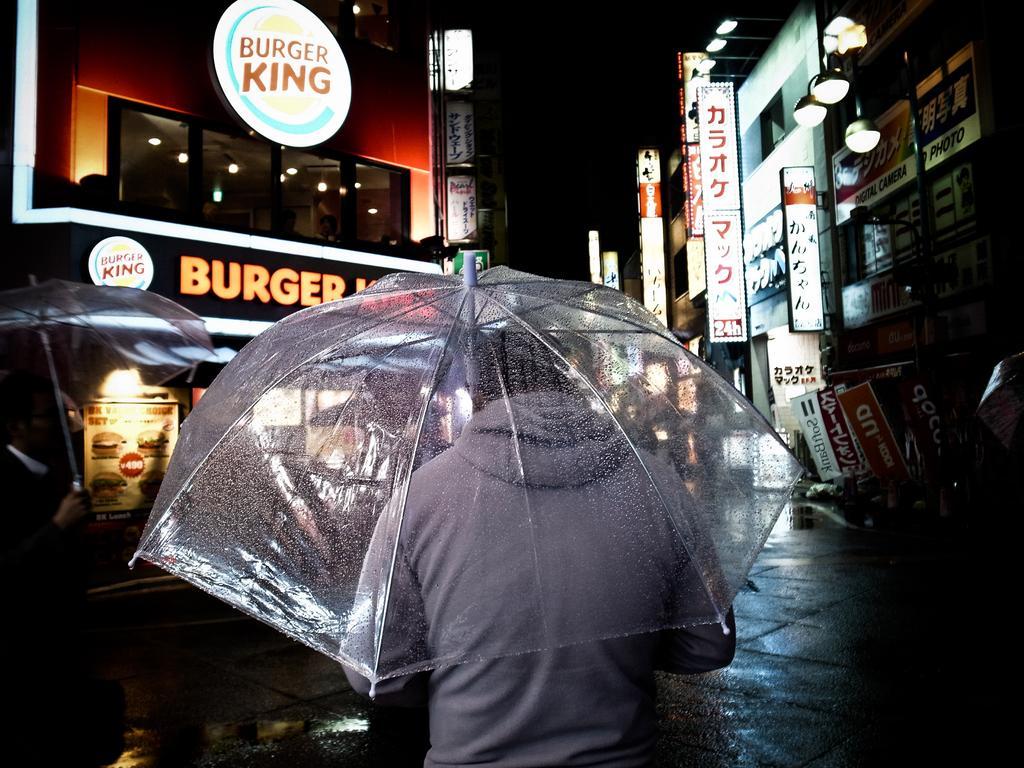Please provide a concise description of this image. This picture is clicked in the dark. I can see lights and shops of the buildings on both sides of the road and I can see people holding umbrellas. It seems it's raining.  